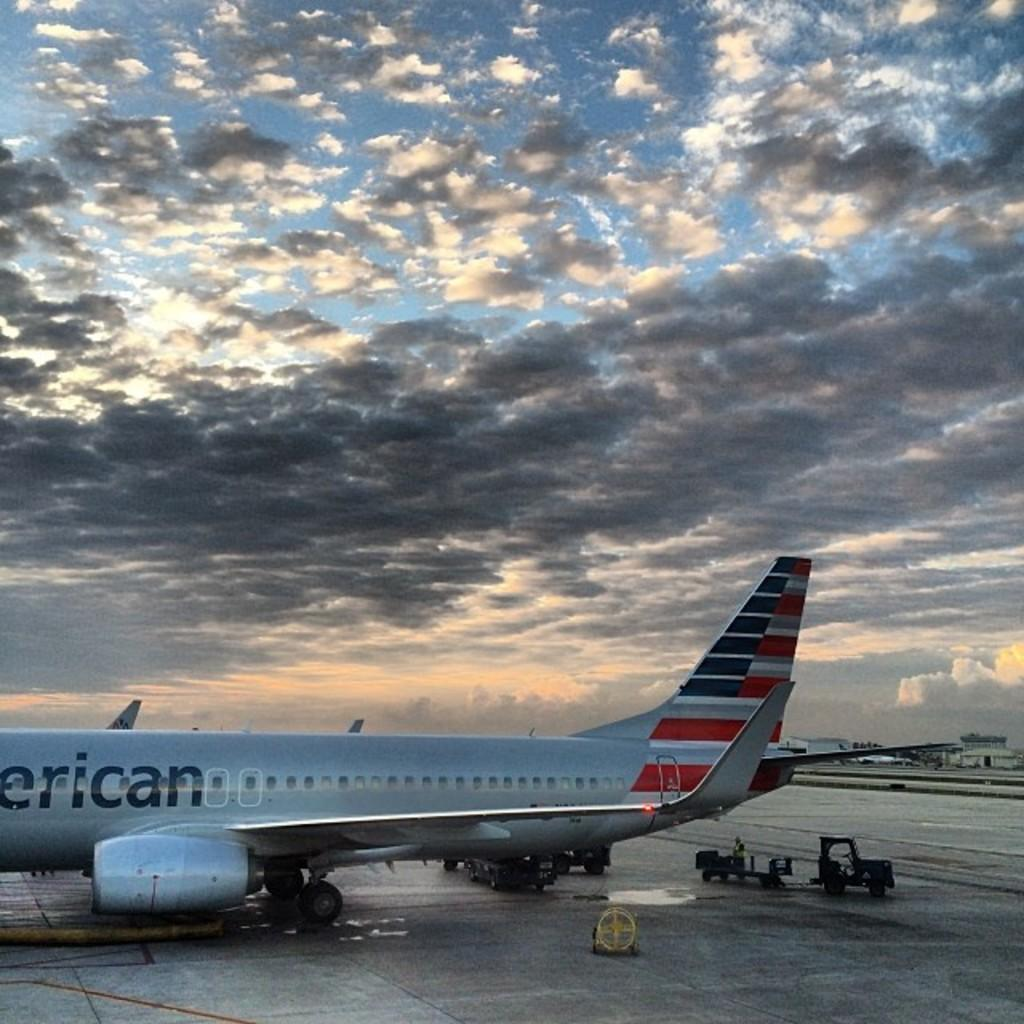What is the main subject of the image? The main subject of the image is an aeroplane on the runway. What else can be seen on the right side of the image? There is a luggage carrier on the right side of the image. What is visible in the background of the image? There is a building and the sky visible in the background of the image. What can be observed about the sky in the image? The sky in the image has clouds. Can you describe the sense of smell in the image? There is no information about the sense of smell in the image, as it focuses on visual elements such as the aeroplane, luggage carrier, building, and sky. 